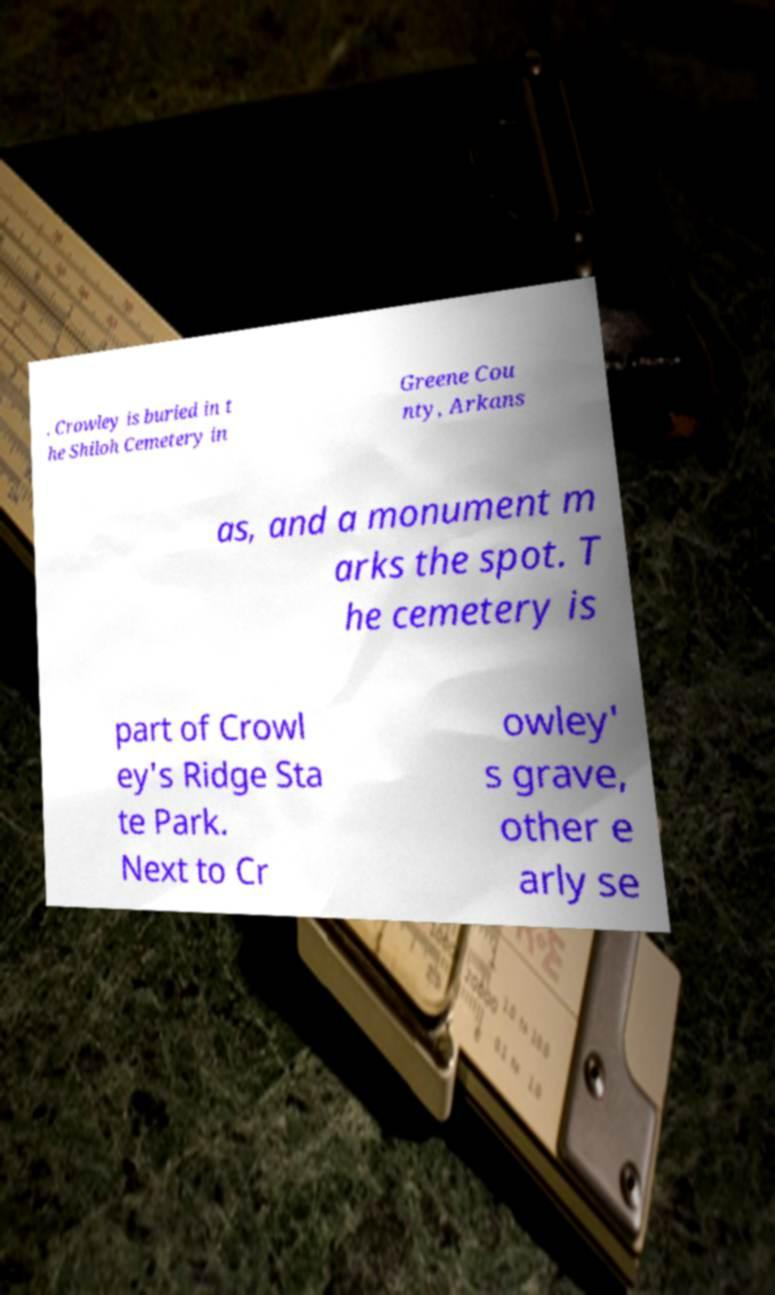Could you extract and type out the text from this image? . Crowley is buried in t he Shiloh Cemetery in Greene Cou nty, Arkans as, and a monument m arks the spot. T he cemetery is part of Crowl ey's Ridge Sta te Park. Next to Cr owley' s grave, other e arly se 